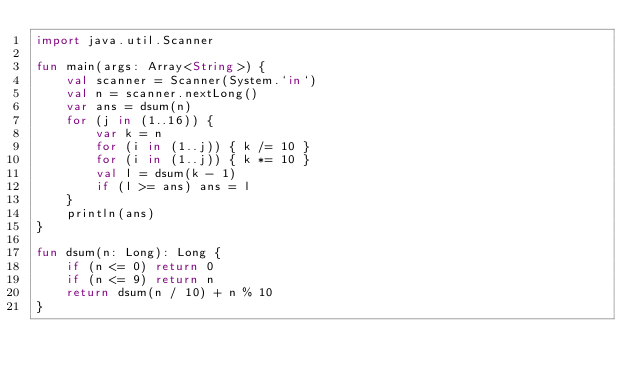Convert code to text. <code><loc_0><loc_0><loc_500><loc_500><_Kotlin_>import java.util.Scanner

fun main(args: Array<String>) {
    val scanner = Scanner(System.`in`)
    val n = scanner.nextLong()
    var ans = dsum(n)
    for (j in (1..16)) {
        var k = n
        for (i in (1..j)) { k /= 10 }
        for (i in (1..j)) { k *= 10 }
        val l = dsum(k - 1)
        if (l >= ans) ans = l
    }
    println(ans)
}

fun dsum(n: Long): Long {
    if (n <= 0) return 0
    if (n <= 9) return n
    return dsum(n / 10) + n % 10
}</code> 